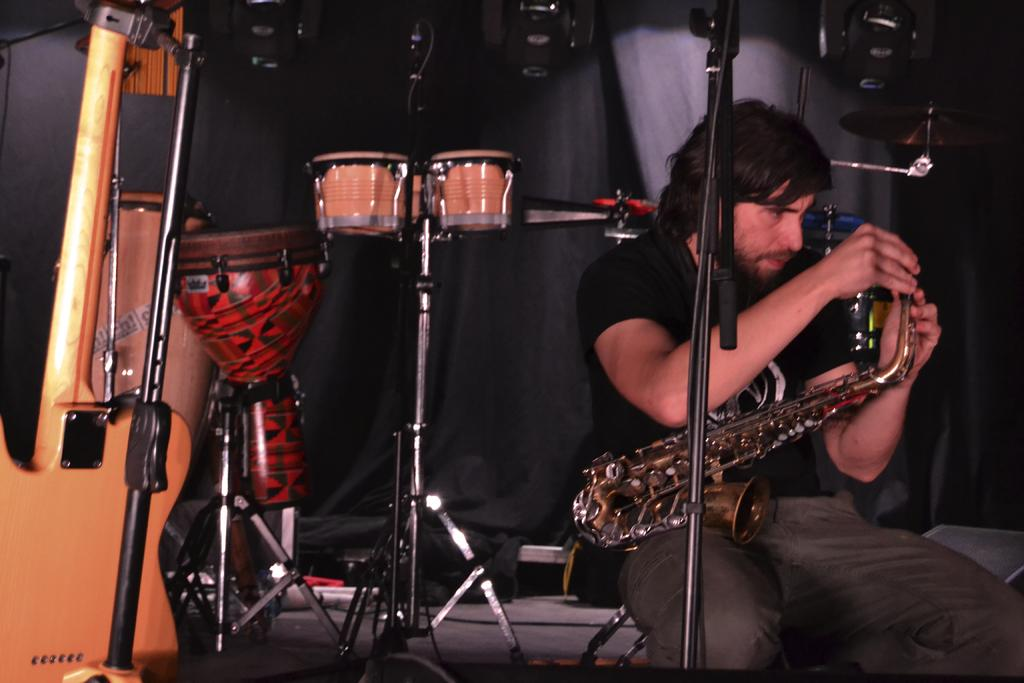Who is in the image? There is a person in the image. What is the person wearing? The person is wearing a black shirt. What is the person doing in the image? The person is setting a trumpet. What else can be seen in the image related to music? There are musical instruments behind the person. How many animals are in the flock behind the person in the image? There are no animals or flock present in the image; it features a person setting a trumpet and other musical instruments. 